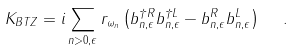Convert formula to latex. <formula><loc_0><loc_0><loc_500><loc_500>K _ { B T Z } = i \sum _ { n > 0 , \epsilon } r _ { \omega _ { n } } \left ( b _ { n , \epsilon } ^ { \dagger R } b _ { n , \epsilon } ^ { \dagger L } - b _ { n , \epsilon } ^ { R } b _ { n , \epsilon } ^ { L } \right ) \ \ .</formula> 